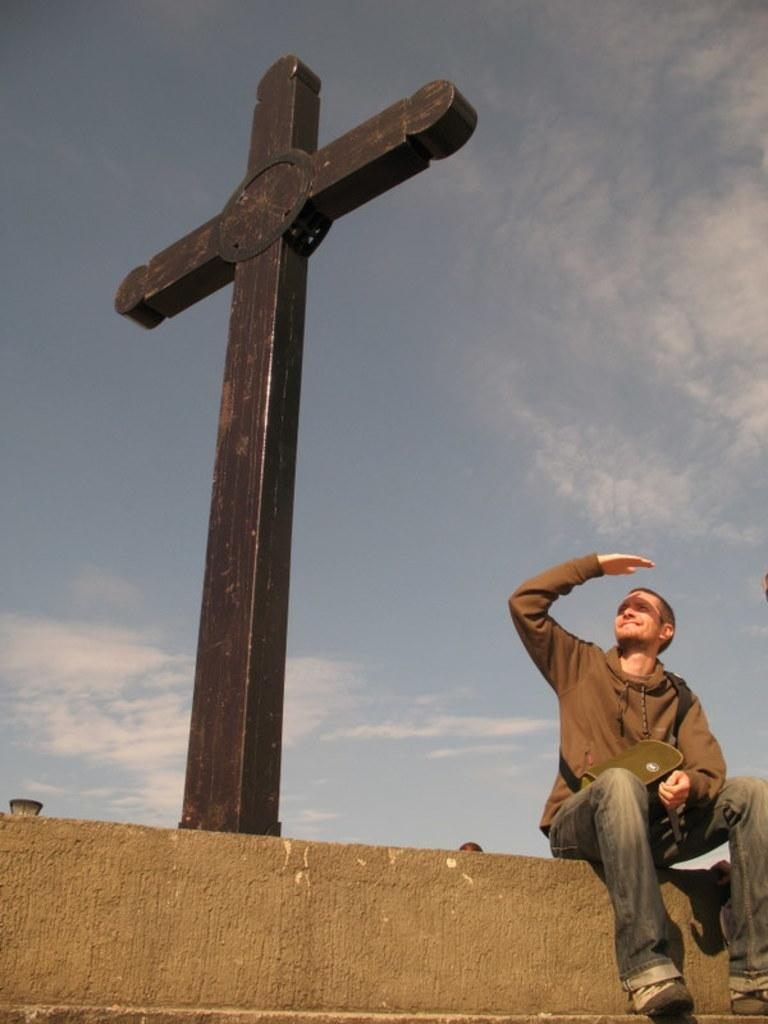What is the man in the image doing? The man is sitting on the wall in the image. What religious symbol can be seen in the image? There is a holy cross symbol in the image. What is visible at the top of the image? The sky is visible at the top of the image. How does the man in the image receive a shock from the wall? There is no indication in the image that the man is receiving a shock from the wall. 